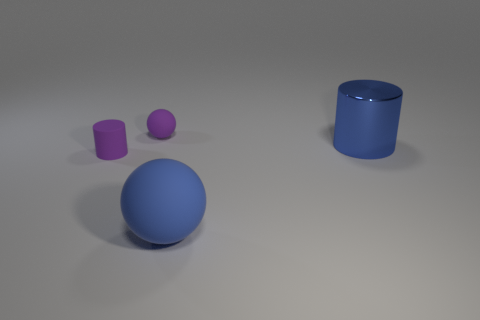Add 3 blue cylinders. How many objects exist? 7 Subtract all purple spheres. How many spheres are left? 1 Subtract all green cylinders. Subtract all cyan cubes. How many cylinders are left? 2 Subtract all tiny purple balls. Subtract all large purple matte blocks. How many objects are left? 3 Add 4 blue matte spheres. How many blue matte spheres are left? 5 Add 2 big blue objects. How many big blue objects exist? 4 Subtract 0 gray balls. How many objects are left? 4 